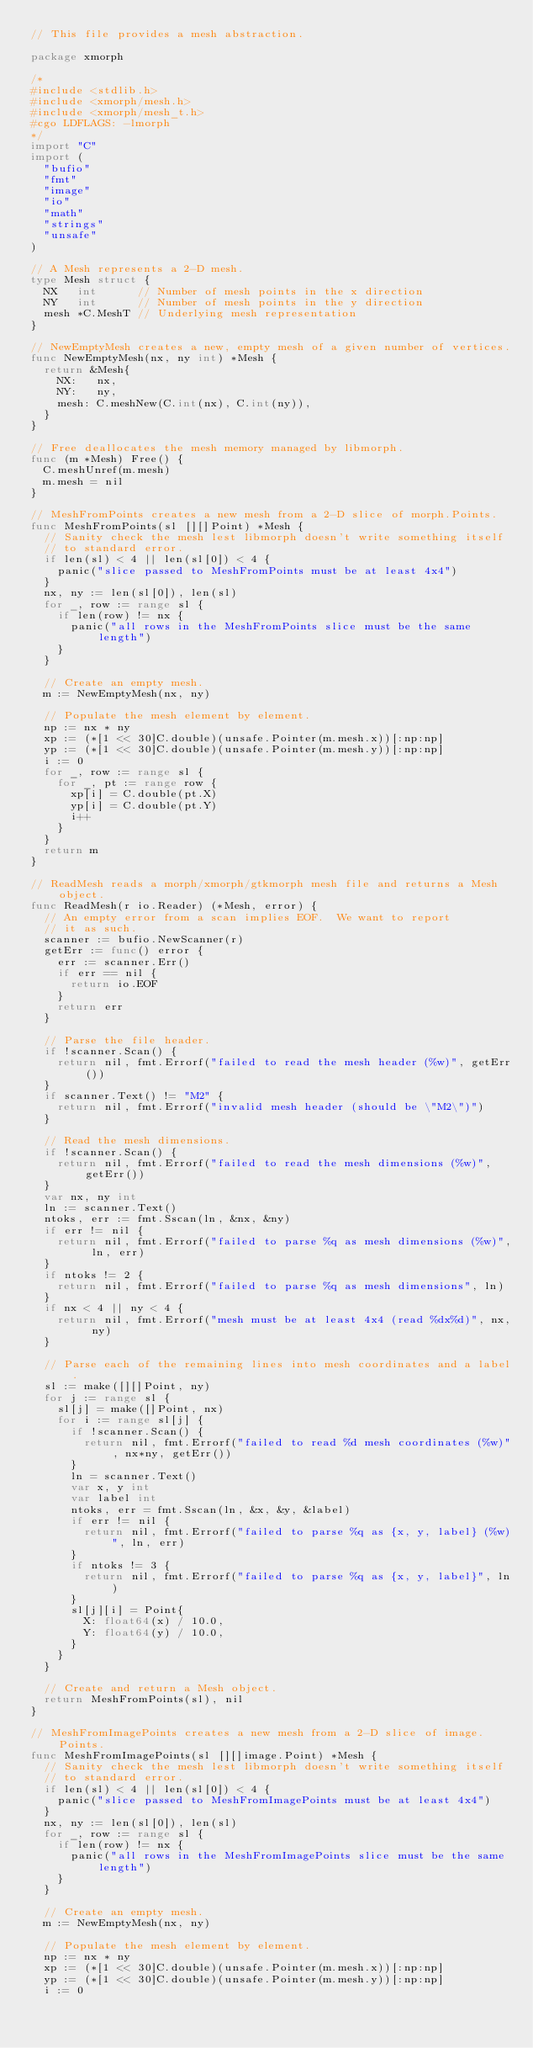Convert code to text. <code><loc_0><loc_0><loc_500><loc_500><_Go_>// This file provides a mesh abstraction.

package xmorph

/*
#include <stdlib.h>
#include <xmorph/mesh.h>
#include <xmorph/mesh_t.h>
#cgo LDFLAGS: -lmorph
*/
import "C"
import (
	"bufio"
	"fmt"
	"image"
	"io"
	"math"
	"strings"
	"unsafe"
)

// A Mesh represents a 2-D mesh.
type Mesh struct {
	NX   int      // Number of mesh points in the x direction
	NY   int      // Number of mesh points in the y direction
	mesh *C.MeshT // Underlying mesh representation
}

// NewEmptyMesh creates a new, empty mesh of a given number of vertices.
func NewEmptyMesh(nx, ny int) *Mesh {
	return &Mesh{
		NX:   nx,
		NY:   ny,
		mesh: C.meshNew(C.int(nx), C.int(ny)),
	}
}

// Free deallocates the mesh memory managed by libmorph.
func (m *Mesh) Free() {
	C.meshUnref(m.mesh)
	m.mesh = nil
}

// MeshFromPoints creates a new mesh from a 2-D slice of morph.Points.
func MeshFromPoints(sl [][]Point) *Mesh {
	// Sanity check the mesh lest libmorph doesn't write something itself
	// to standard error.
	if len(sl) < 4 || len(sl[0]) < 4 {
		panic("slice passed to MeshFromPoints must be at least 4x4")
	}
	nx, ny := len(sl[0]), len(sl)
	for _, row := range sl {
		if len(row) != nx {
			panic("all rows in the MeshFromPoints slice must be the same length")
		}
	}

	// Create an empty mesh.
	m := NewEmptyMesh(nx, ny)

	// Populate the mesh element by element.
	np := nx * ny
	xp := (*[1 << 30]C.double)(unsafe.Pointer(m.mesh.x))[:np:np]
	yp := (*[1 << 30]C.double)(unsafe.Pointer(m.mesh.y))[:np:np]
	i := 0
	for _, row := range sl {
		for _, pt := range row {
			xp[i] = C.double(pt.X)
			yp[i] = C.double(pt.Y)
			i++
		}
	}
	return m
}

// ReadMesh reads a morph/xmorph/gtkmorph mesh file and returns a Mesh object.
func ReadMesh(r io.Reader) (*Mesh, error) {
	// An empty error from a scan implies EOF.  We want to report
	// it as such.
	scanner := bufio.NewScanner(r)
	getErr := func() error {
		err := scanner.Err()
		if err == nil {
			return io.EOF
		}
		return err
	}

	// Parse the file header.
	if !scanner.Scan() {
		return nil, fmt.Errorf("failed to read the mesh header (%w)", getErr())
	}
	if scanner.Text() != "M2" {
		return nil, fmt.Errorf("invalid mesh header (should be \"M2\")")
	}

	// Read the mesh dimensions.
	if !scanner.Scan() {
		return nil, fmt.Errorf("failed to read the mesh dimensions (%w)", getErr())
	}
	var nx, ny int
	ln := scanner.Text()
	ntoks, err := fmt.Sscan(ln, &nx, &ny)
	if err != nil {
		return nil, fmt.Errorf("failed to parse %q as mesh dimensions (%w)", ln, err)
	}
	if ntoks != 2 {
		return nil, fmt.Errorf("failed to parse %q as mesh dimensions", ln)
	}
	if nx < 4 || ny < 4 {
		return nil, fmt.Errorf("mesh must be at least 4x4 (read %dx%d)", nx, ny)
	}

	// Parse each of the remaining lines into mesh coordinates and a label.
	sl := make([][]Point, ny)
	for j := range sl {
		sl[j] = make([]Point, nx)
		for i := range sl[j] {
			if !scanner.Scan() {
				return nil, fmt.Errorf("failed to read %d mesh coordinates (%w)", nx*ny, getErr())
			}
			ln = scanner.Text()
			var x, y int
			var label int
			ntoks, err = fmt.Sscan(ln, &x, &y, &label)
			if err != nil {
				return nil, fmt.Errorf("failed to parse %q as {x, y, label} (%w)", ln, err)
			}
			if ntoks != 3 {
				return nil, fmt.Errorf("failed to parse %q as {x, y, label}", ln)
			}
			sl[j][i] = Point{
				X: float64(x) / 10.0,
				Y: float64(y) / 10.0,
			}
		}
	}

	// Create and return a Mesh object.
	return MeshFromPoints(sl), nil
}

// MeshFromImagePoints creates a new mesh from a 2-D slice of image.Points.
func MeshFromImagePoints(sl [][]image.Point) *Mesh {
	// Sanity check the mesh lest libmorph doesn't write something itself
	// to standard error.
	if len(sl) < 4 || len(sl[0]) < 4 {
		panic("slice passed to MeshFromImagePoints must be at least 4x4")
	}
	nx, ny := len(sl[0]), len(sl)
	for _, row := range sl {
		if len(row) != nx {
			panic("all rows in the MeshFromImagePoints slice must be the same length")
		}
	}

	// Create an empty mesh.
	m := NewEmptyMesh(nx, ny)

	// Populate the mesh element by element.
	np := nx * ny
	xp := (*[1 << 30]C.double)(unsafe.Pointer(m.mesh.x))[:np:np]
	yp := (*[1 << 30]C.double)(unsafe.Pointer(m.mesh.y))[:np:np]
	i := 0</code> 